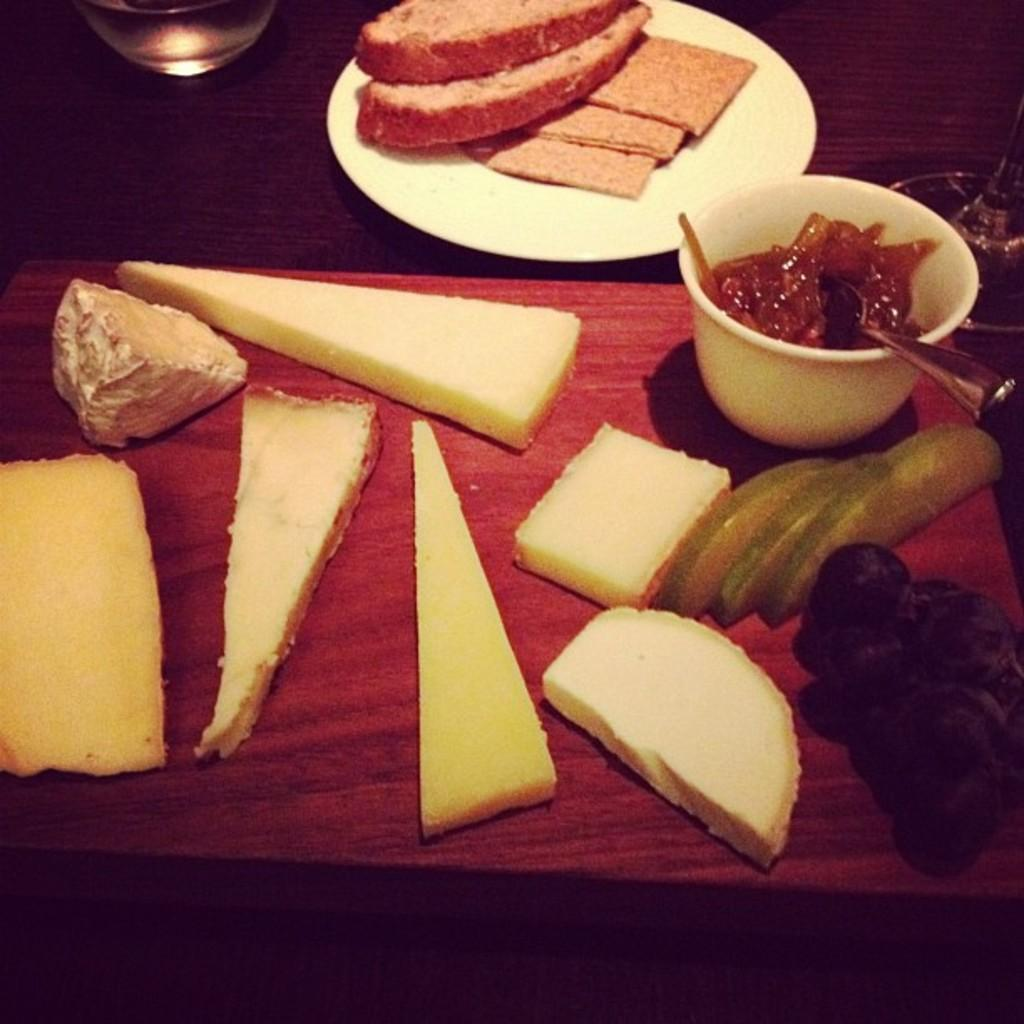What type of food items can be seen in the image? There are bread slices, fruits, and jam in the image. Are there any other food items present besides these? Yes, there are other food items in the image. What is the container for the jam? The jam is in a container, which is not specified in the facts. What is the purpose of the glass in the image? The purpose of the glass is not specified in the facts. Where are all these items placed? All of these items are placed on a table. How many geese are present in the image? There are no geese present in the image. What decision does the judge make in the image? There is no judge or decision-making process depicted in the image. 